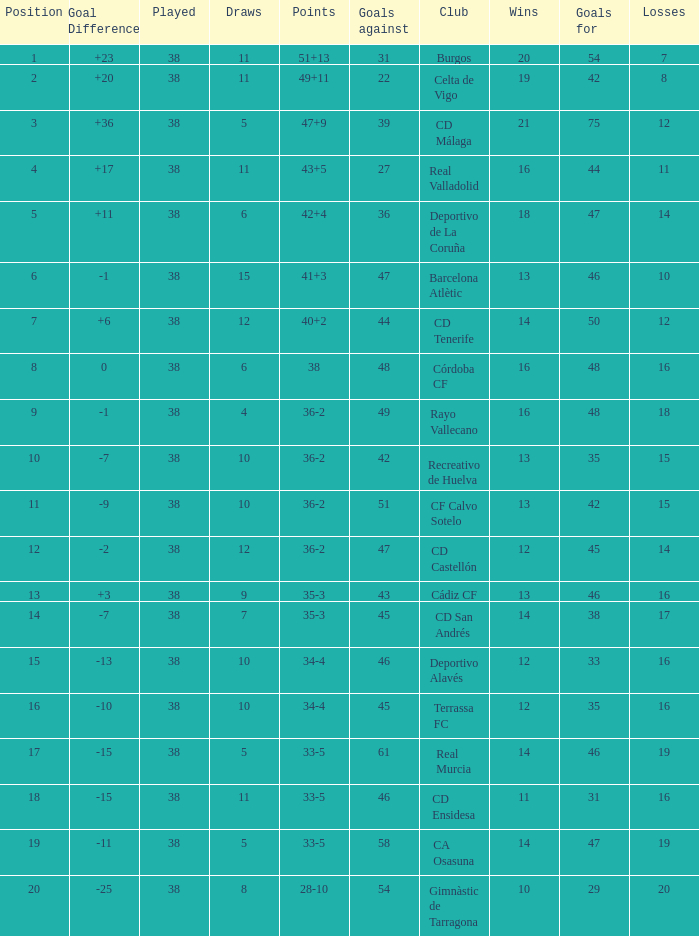What is the average loss with a goal higher than 51 and wins higher than 14? None. 